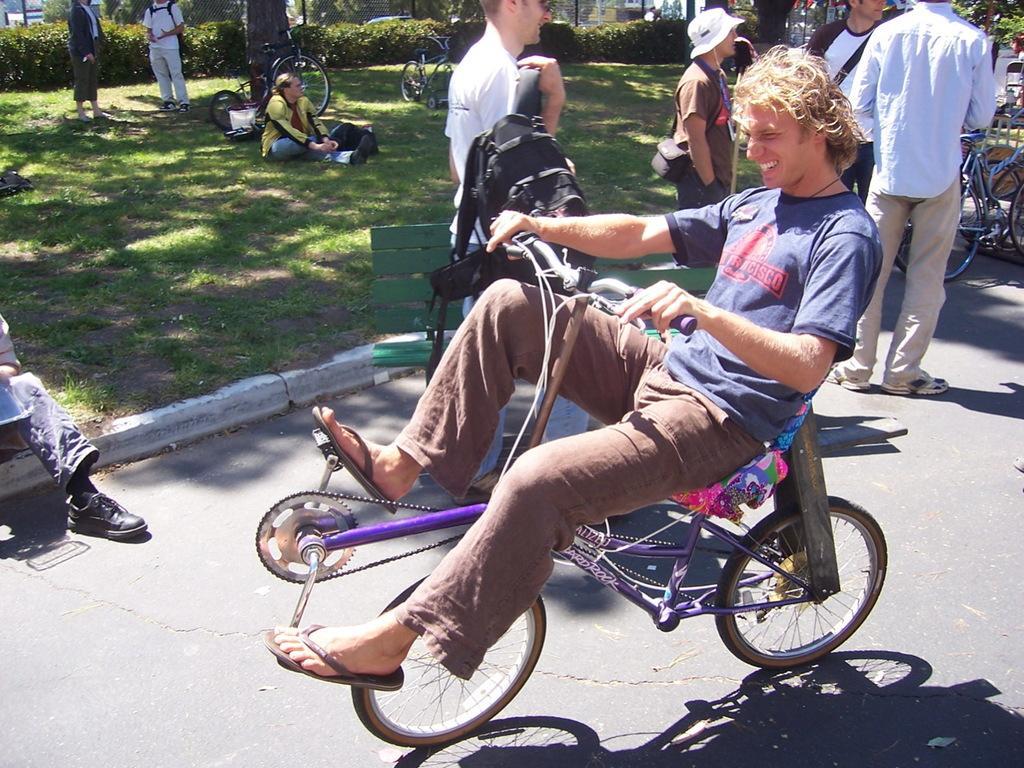Could you give a brief overview of what you see in this image? This is a picture taken in the outdoors. The man in blue t shirt was riding a bicycle on road. behind the man there is a bench in green color and group of people are standing on the floor and a man in yellow jacket was sitting on grass and there are bushes and trees. 